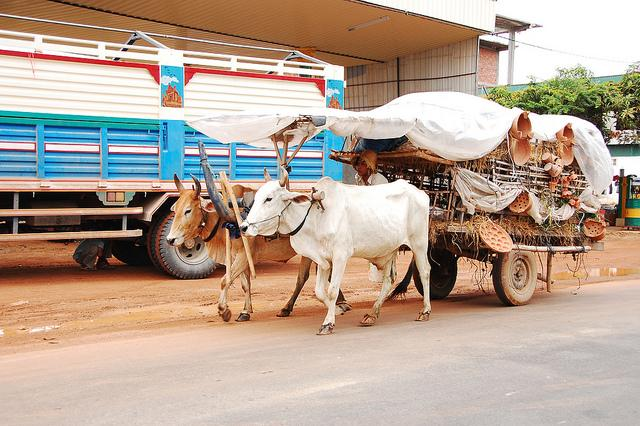What are the bulls doing? Please explain your reasoning. working. The bulls are pulling a load. 